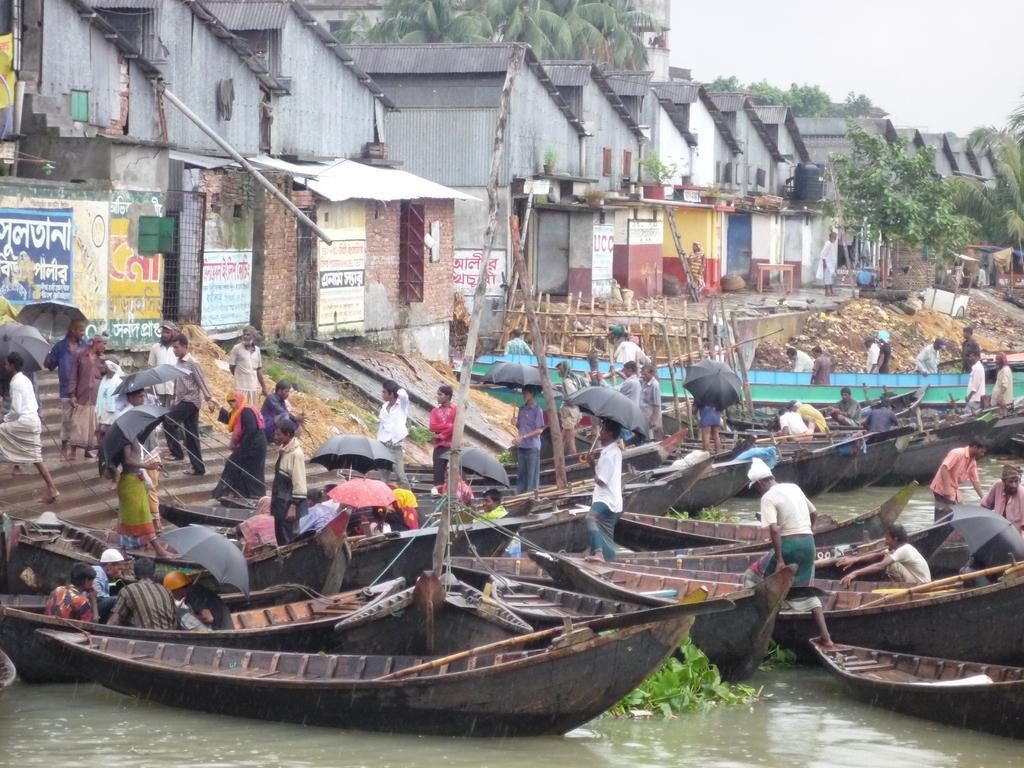Please provide a concise description of this image. At the top of the image we can see sky, trees, overhead tanks, sheds and advertisements on the walls. At the bottom of the image we can see persons standing on stairs and boats by holding umbrellas in their hands and some are sitting on the boats above the water. 